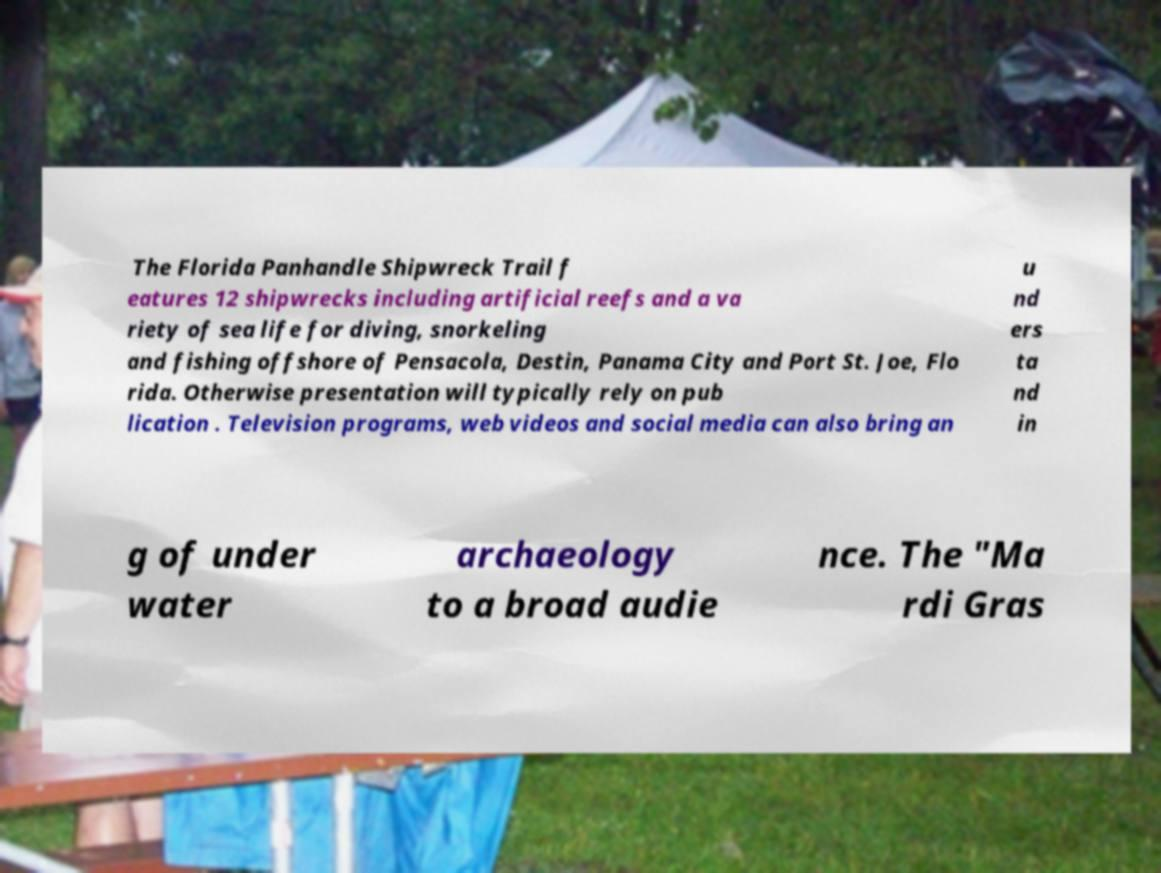Could you extract and type out the text from this image? The Florida Panhandle Shipwreck Trail f eatures 12 shipwrecks including artificial reefs and a va riety of sea life for diving, snorkeling and fishing offshore of Pensacola, Destin, Panama City and Port St. Joe, Flo rida. Otherwise presentation will typically rely on pub lication . Television programs, web videos and social media can also bring an u nd ers ta nd in g of under water archaeology to a broad audie nce. The "Ma rdi Gras 